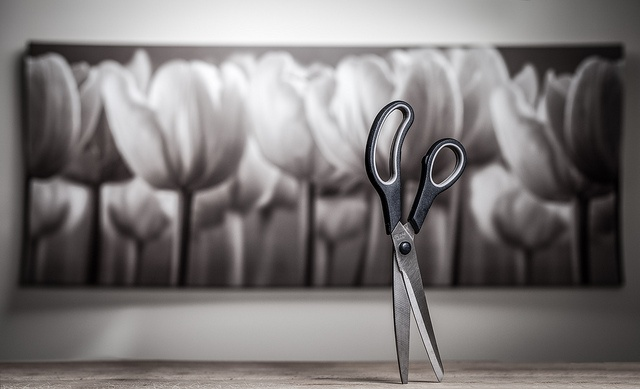Describe the objects in this image and their specific colors. I can see scissors in gray, black, darkgray, and lightgray tones in this image. 